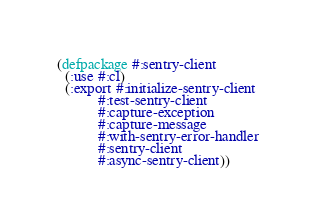<code> <loc_0><loc_0><loc_500><loc_500><_Lisp_>(defpackage #:sentry-client
  (:use #:cl)
  (:export #:initialize-sentry-client
           #:test-sentry-client
           #:capture-exception
           #:capture-message
           #:with-sentry-error-handler
           #:sentry-client
           #:async-sentry-client))
</code> 